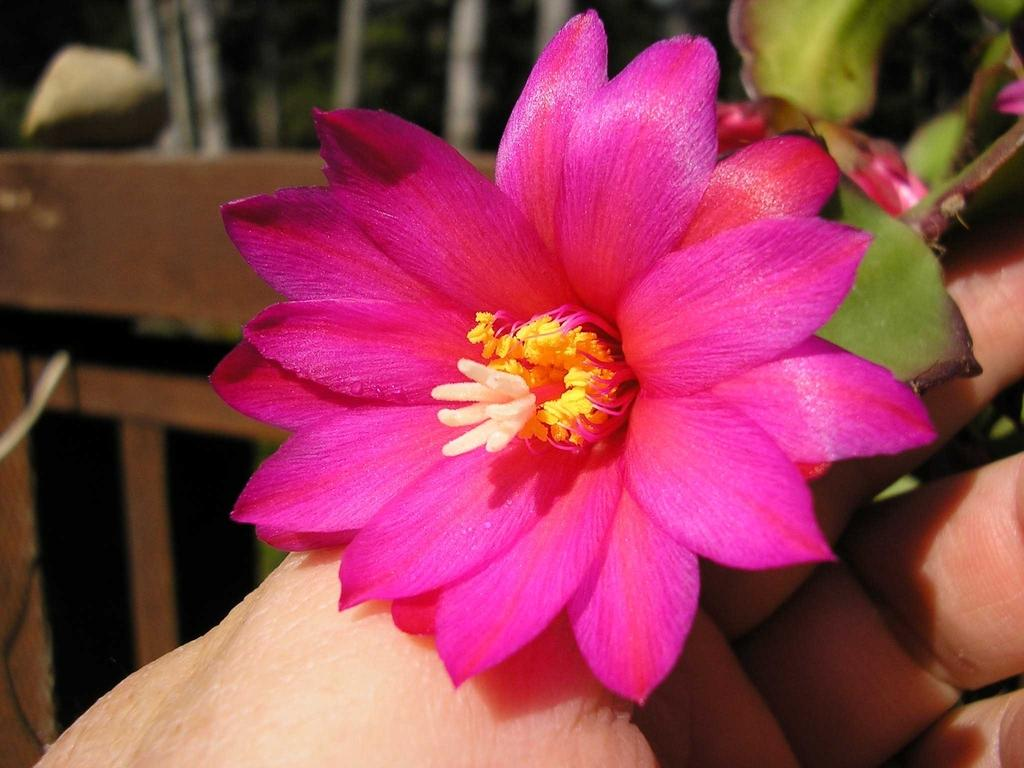What is the main subject of the image? The main subject of the image is a flower. How is the flower being held in the image? The flower is being held in a hand. Where is the plantation located in the image? There is no plantation present in the image; it only features a flower being held in a hand. How many people are working at the harbor in the image? There is no harbor or people present in the image; it only features a flower being held in a hand. 